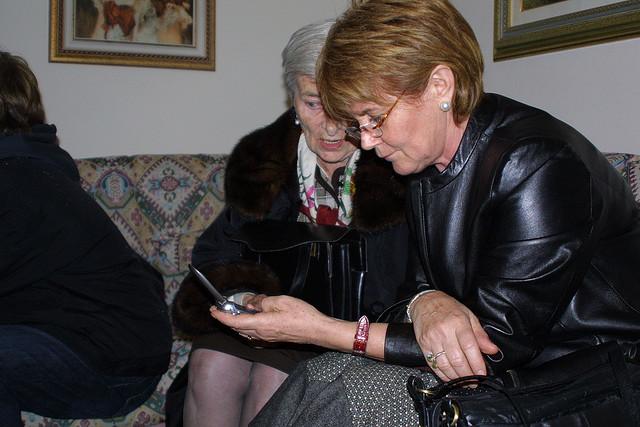What is the woman looking at?
Concise answer only. Phone. Who has glasses on?
Be succinct. Woman. What color is the woman's watch?
Quick response, please. Red. 